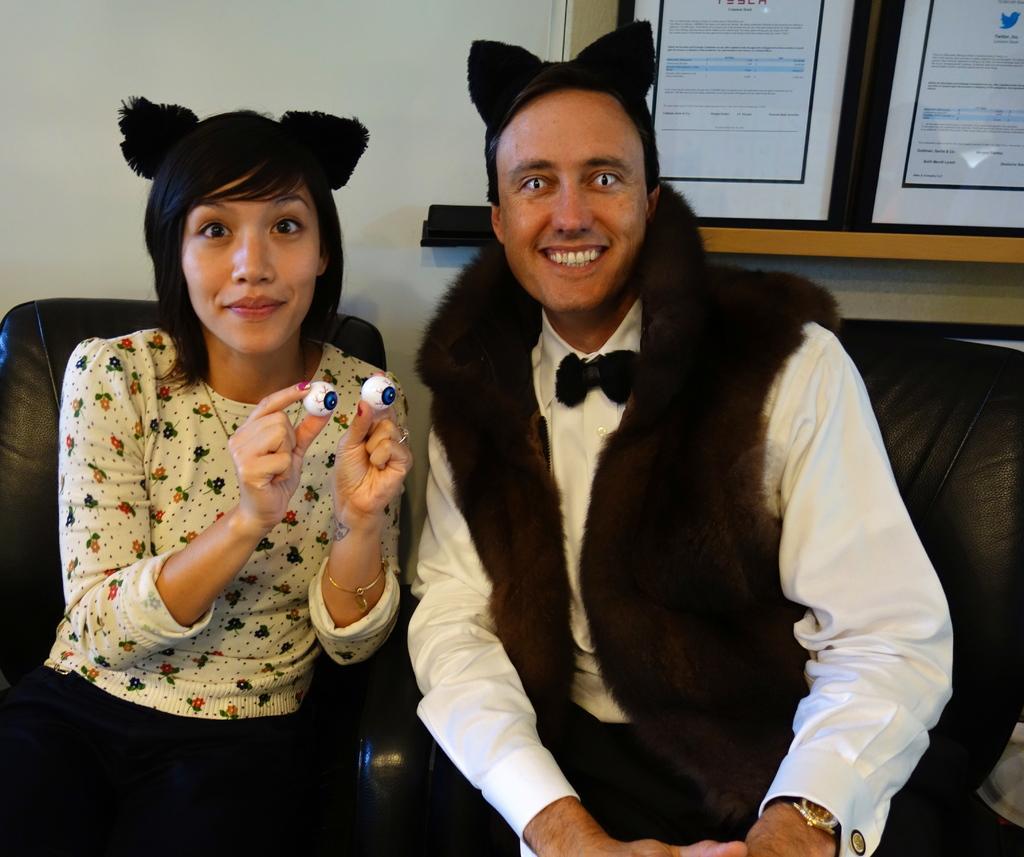In one or two sentences, can you explain what this image depicts? There are two people sitting on chair and she is holding objects,behind these two people we can see wall and frames on the wooden surface. 